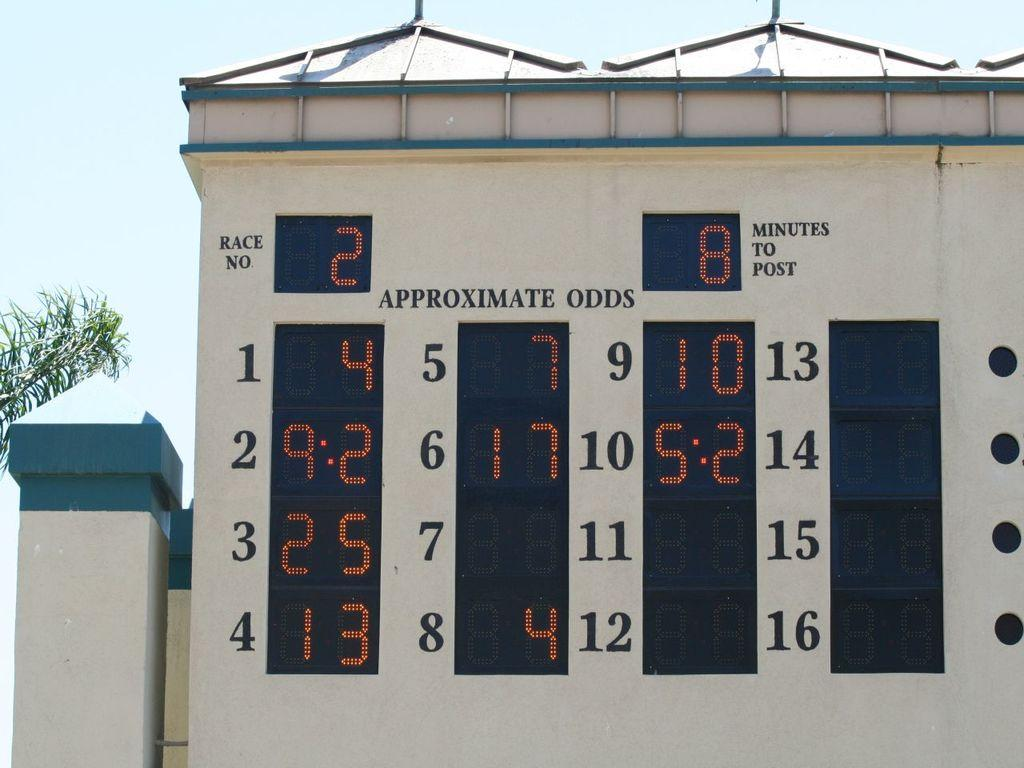Provide a one-sentence caption for the provided image. wall with electronic board showing the odds for race number 2. 